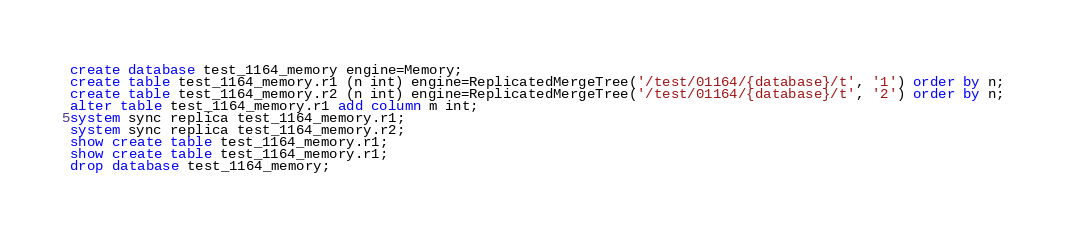<code> <loc_0><loc_0><loc_500><loc_500><_SQL_>create database test_1164_memory engine=Memory;
create table test_1164_memory.r1 (n int) engine=ReplicatedMergeTree('/test/01164/{database}/t', '1') order by n;
create table test_1164_memory.r2 (n int) engine=ReplicatedMergeTree('/test/01164/{database}/t', '2') order by n;
alter table test_1164_memory.r1 add column m int;
system sync replica test_1164_memory.r1;
system sync replica test_1164_memory.r2;
show create table test_1164_memory.r1;
show create table test_1164_memory.r1;
drop database test_1164_memory;
</code> 